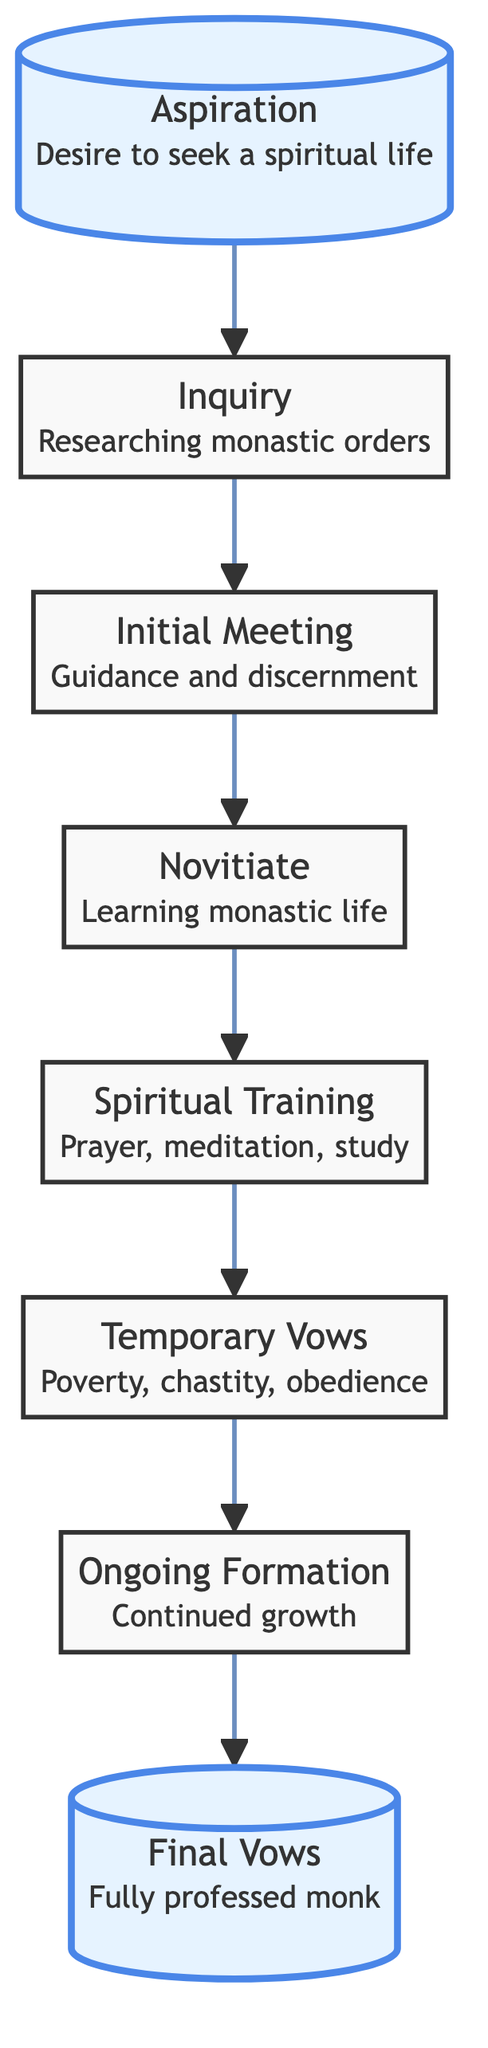What is the first stage in the journey of a monk? The first stage listed in the flowchart is "Aspiration," which represents the desire to seek a spiritual life and join a monastic community.
Answer: Aspiration How many total stages are present in the flowchart? Counting the stages from "Aspiration" to "Final Vows," there are a total of eight distinct stages outlined in the flowchart.
Answer: 8 What comes after "Initial Meeting"? According to the flowchart, after "Initial Meeting," the next stage is "Novitiate," indicating the entry into the community as a novice.
Answer: Novitiate Which stage involves taking temporary vows? The stage that involves taking temporary vows of poverty, chastity, and obedience is called "Temporary Vows," according to the sequence in the diagram.
Answer: Temporary Vows What does "Ongoing Formation" signify in the journey? "Ongoing Formation" refers to the continued spiritual growth and assignments that a monk takes on within the monastic community, as per the diagram.
Answer: Continued growth What links "Aspiration" to "Inquiry"? The flowchart illustrates a direct connection or link from "Aspiration" to "Inquiry," indicating the progression from the desire to join the monastic life to researching different monastic orders.
Answer: Inquiry What is the significance of "Final Vows" in the diagram? "Final Vows" is the concluding stage in the flowchart, emphasizing the commitment of a monk who takes permanent vows to become a fully professed member of the monastic order.
Answer: Fully professed monk After "Spiritual Training," what is the next step? Following "Spiritual Training," the next step in the flowchart is "Temporary Vows," indicating the transition from training to commitment through temporary vows.
Answer: Temporary Vows Which two stages are highlighted in the flowchart? The stages highlighted in the flowchart are "Aspiration" and "Final Vows," indicating significant points in the monk's journey.
Answer: Aspiration, Final Vows 